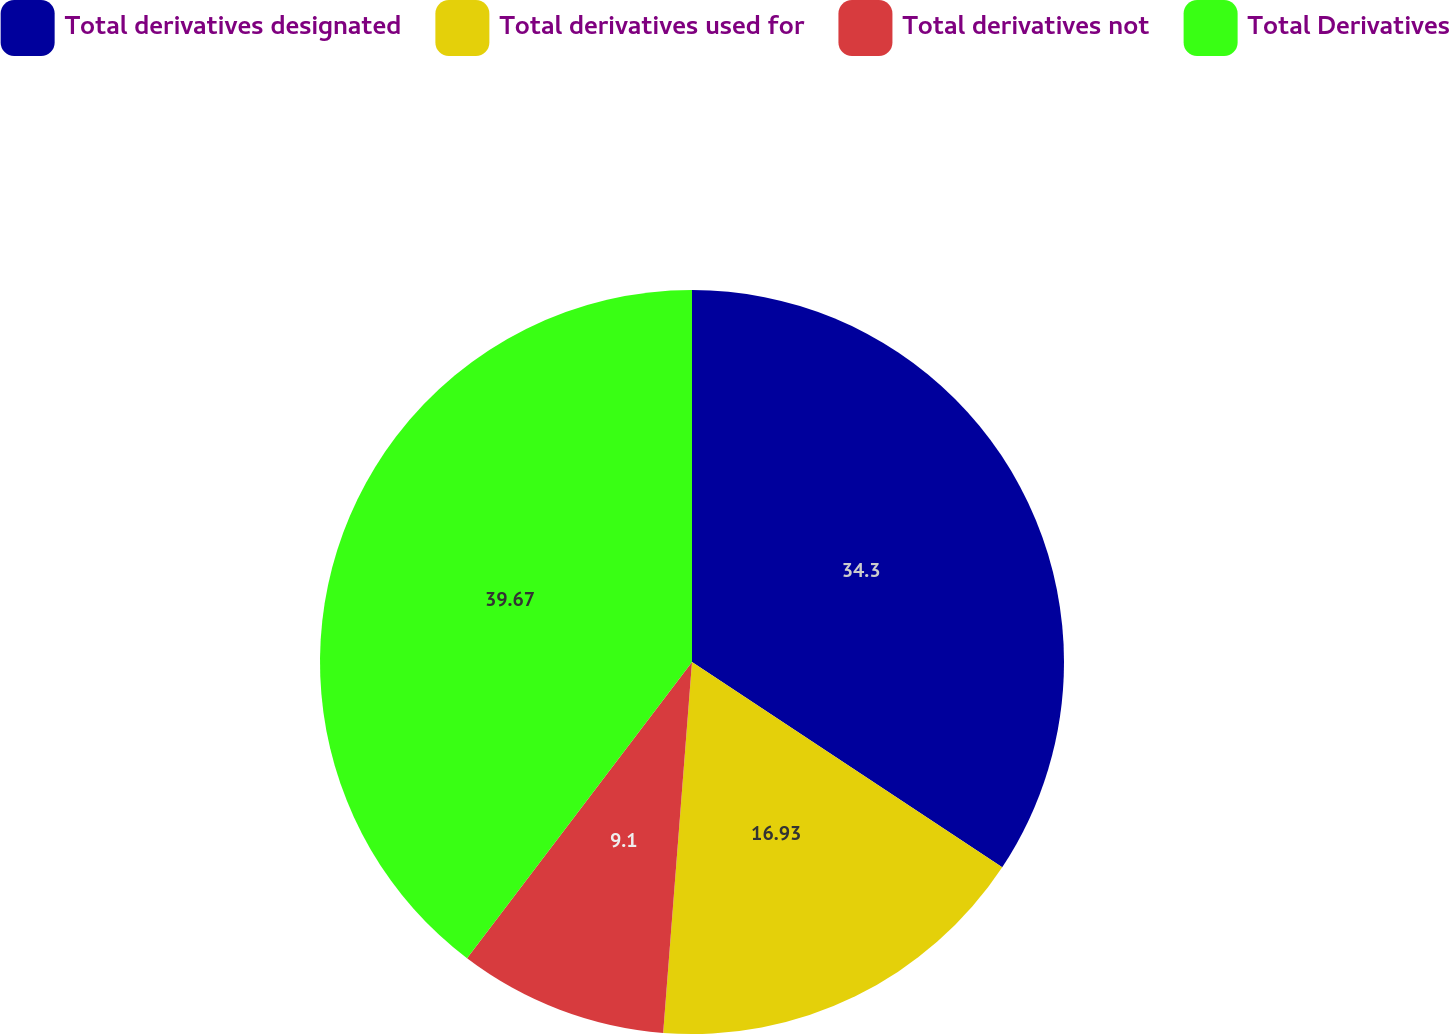Convert chart. <chart><loc_0><loc_0><loc_500><loc_500><pie_chart><fcel>Total derivatives designated<fcel>Total derivatives used for<fcel>Total derivatives not<fcel>Total Derivatives<nl><fcel>34.3%<fcel>16.93%<fcel>9.1%<fcel>39.66%<nl></chart> 